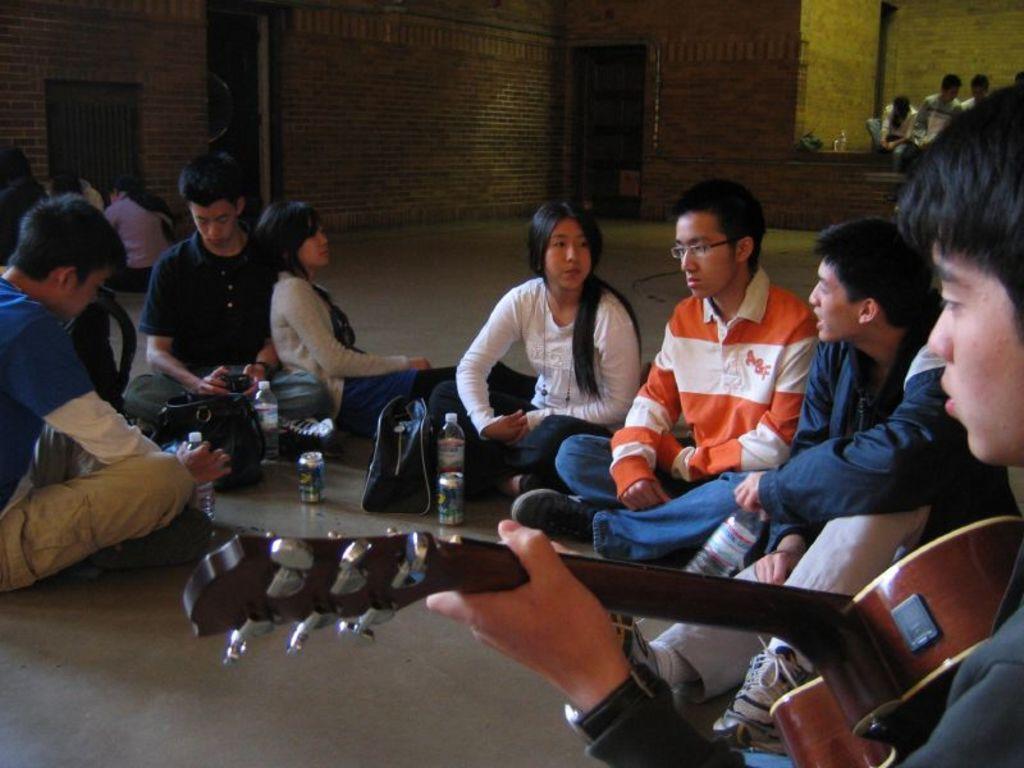How would you summarize this image in a sentence or two? In this image, there are some people sitting on the ground, at the right side there is a boy holding a guitar. 